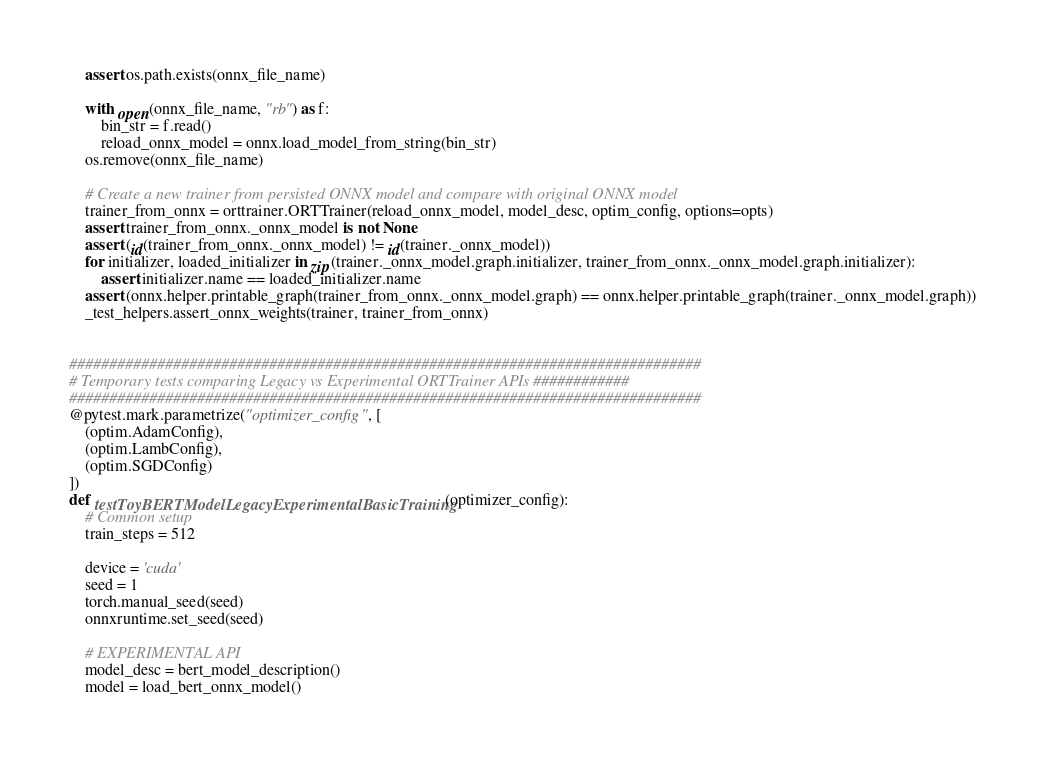Convert code to text. <code><loc_0><loc_0><loc_500><loc_500><_Python_>    assert os.path.exists(onnx_file_name)

    with open(onnx_file_name, "rb") as f:
        bin_str = f.read()
        reload_onnx_model = onnx.load_model_from_string(bin_str)
    os.remove(onnx_file_name)

    # Create a new trainer from persisted ONNX model and compare with original ONNX model
    trainer_from_onnx = orttrainer.ORTTrainer(reload_onnx_model, model_desc, optim_config, options=opts)
    assert trainer_from_onnx._onnx_model is not None
    assert (id(trainer_from_onnx._onnx_model) != id(trainer._onnx_model))
    for initializer, loaded_initializer in zip(trainer._onnx_model.graph.initializer, trainer_from_onnx._onnx_model.graph.initializer):
        assert initializer.name == loaded_initializer.name
    assert (onnx.helper.printable_graph(trainer_from_onnx._onnx_model.graph) == onnx.helper.printable_graph(trainer._onnx_model.graph))
    _test_helpers.assert_onnx_weights(trainer, trainer_from_onnx)


###############################################################################
# Temporary tests comparing Legacy vs Experimental ORTTrainer APIs ############
###############################################################################
@pytest.mark.parametrize("optimizer_config", [
    (optim.AdamConfig),
    (optim.LambConfig),
    (optim.SGDConfig)
])
def testToyBERTModelLegacyExperimentalBasicTraining(optimizer_config):
    # Common setup
    train_steps = 512

    device = 'cuda'
    seed = 1
    torch.manual_seed(seed)
    onnxruntime.set_seed(seed)

    # EXPERIMENTAL API
    model_desc = bert_model_description()
    model = load_bert_onnx_model()</code> 